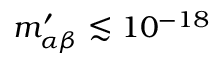Convert formula to latex. <formula><loc_0><loc_0><loc_500><loc_500>m _ { \alpha \beta } ^ { \prime } \lesssim 1 0 ^ { - 1 8 }</formula> 